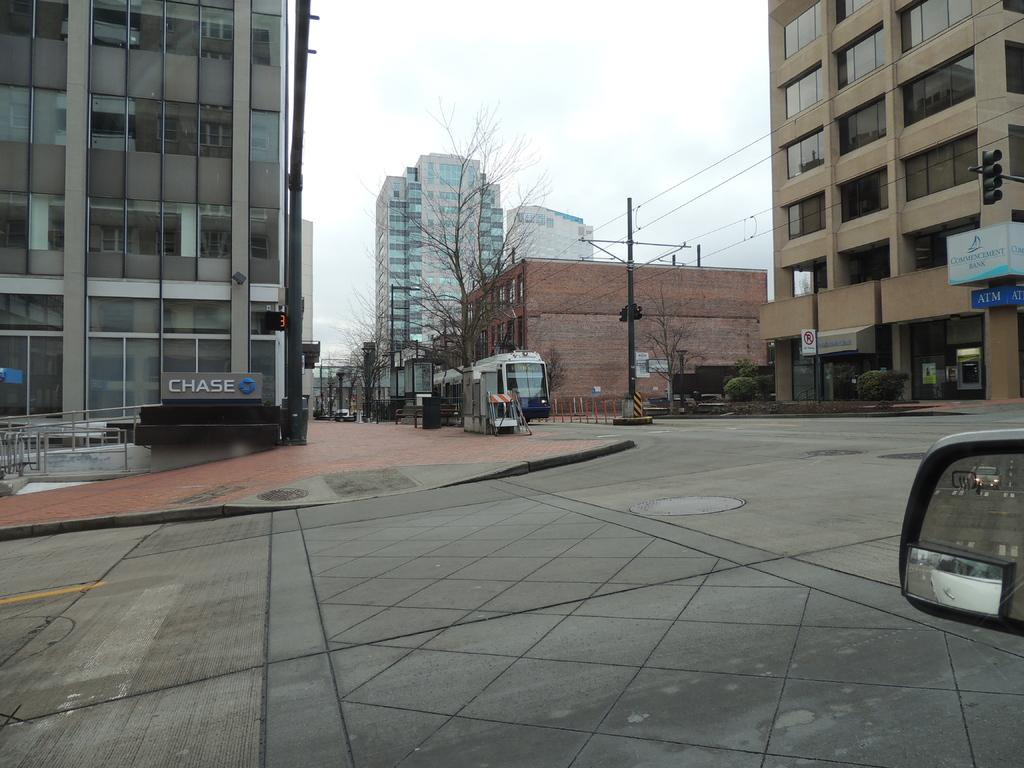What type of structures can be seen in the image? There are buildings in the image. What else can be seen in the image besides buildings? There are poles, lights, trees, plants, and vehicles in the image. What type of oven can be seen in the image? There is no oven present in the image. How many branches are visible on the trees in the image? The image does not specify the number of branches on the trees, as it only mentions that there are trees present. 